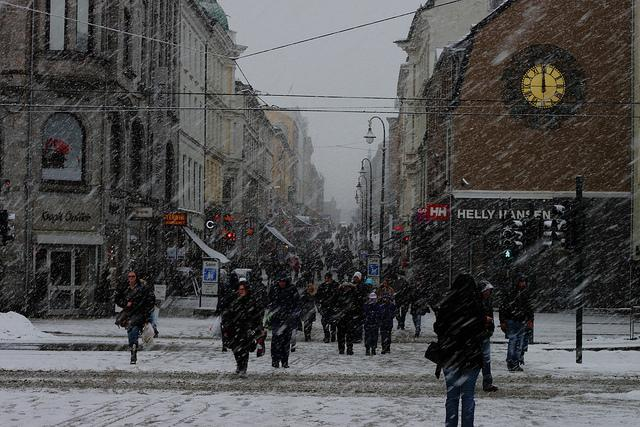What is the composition of the falling material?

Choices:
A) stone
B) brick
C) cloth
D) water water 